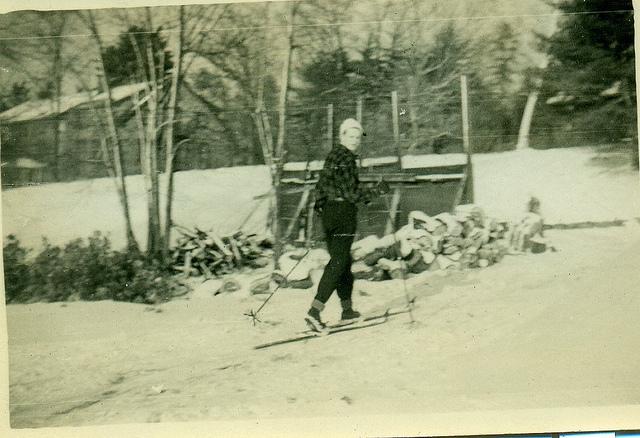Is there any names in the picture?
Write a very short answer. No. What is in the background to the left?
Keep it brief. Building. Where is the man going?
Answer briefly. Skiing. Is this a winter photo?
Quick response, please. Yes. Did the road flood?
Answer briefly. No. Is this a well used ski area?
Quick response, please. Yes. 